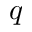<formula> <loc_0><loc_0><loc_500><loc_500>q</formula> 